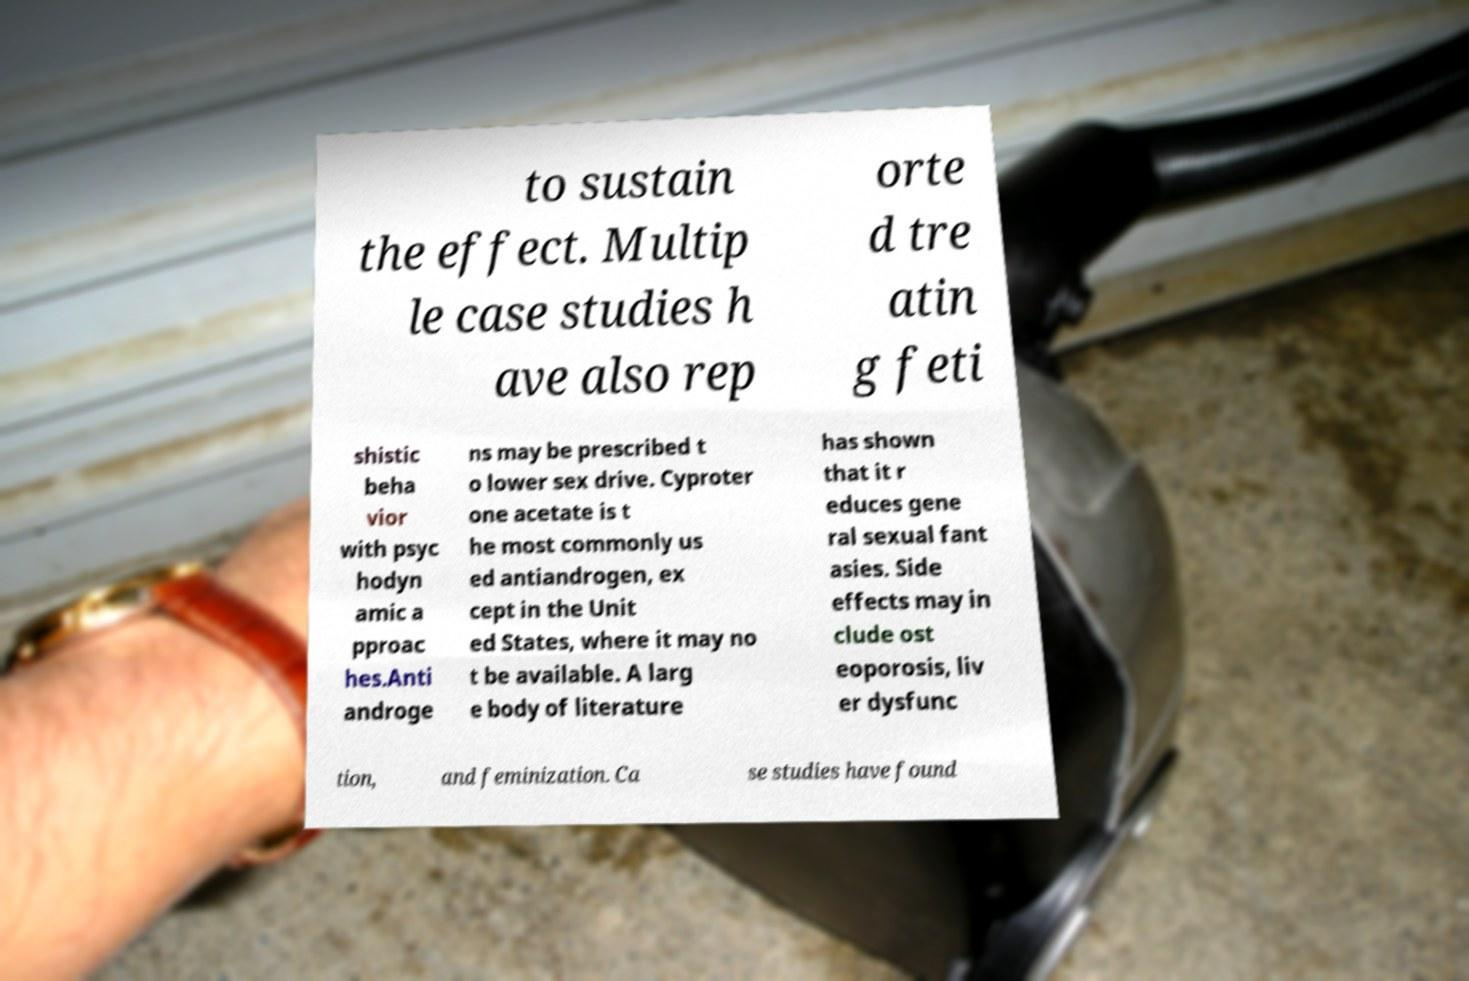I need the written content from this picture converted into text. Can you do that? to sustain the effect. Multip le case studies h ave also rep orte d tre atin g feti shistic beha vior with psyc hodyn amic a pproac hes.Anti androge ns may be prescribed t o lower sex drive. Cyproter one acetate is t he most commonly us ed antiandrogen, ex cept in the Unit ed States, where it may no t be available. A larg e body of literature has shown that it r educes gene ral sexual fant asies. Side effects may in clude ost eoporosis, liv er dysfunc tion, and feminization. Ca se studies have found 